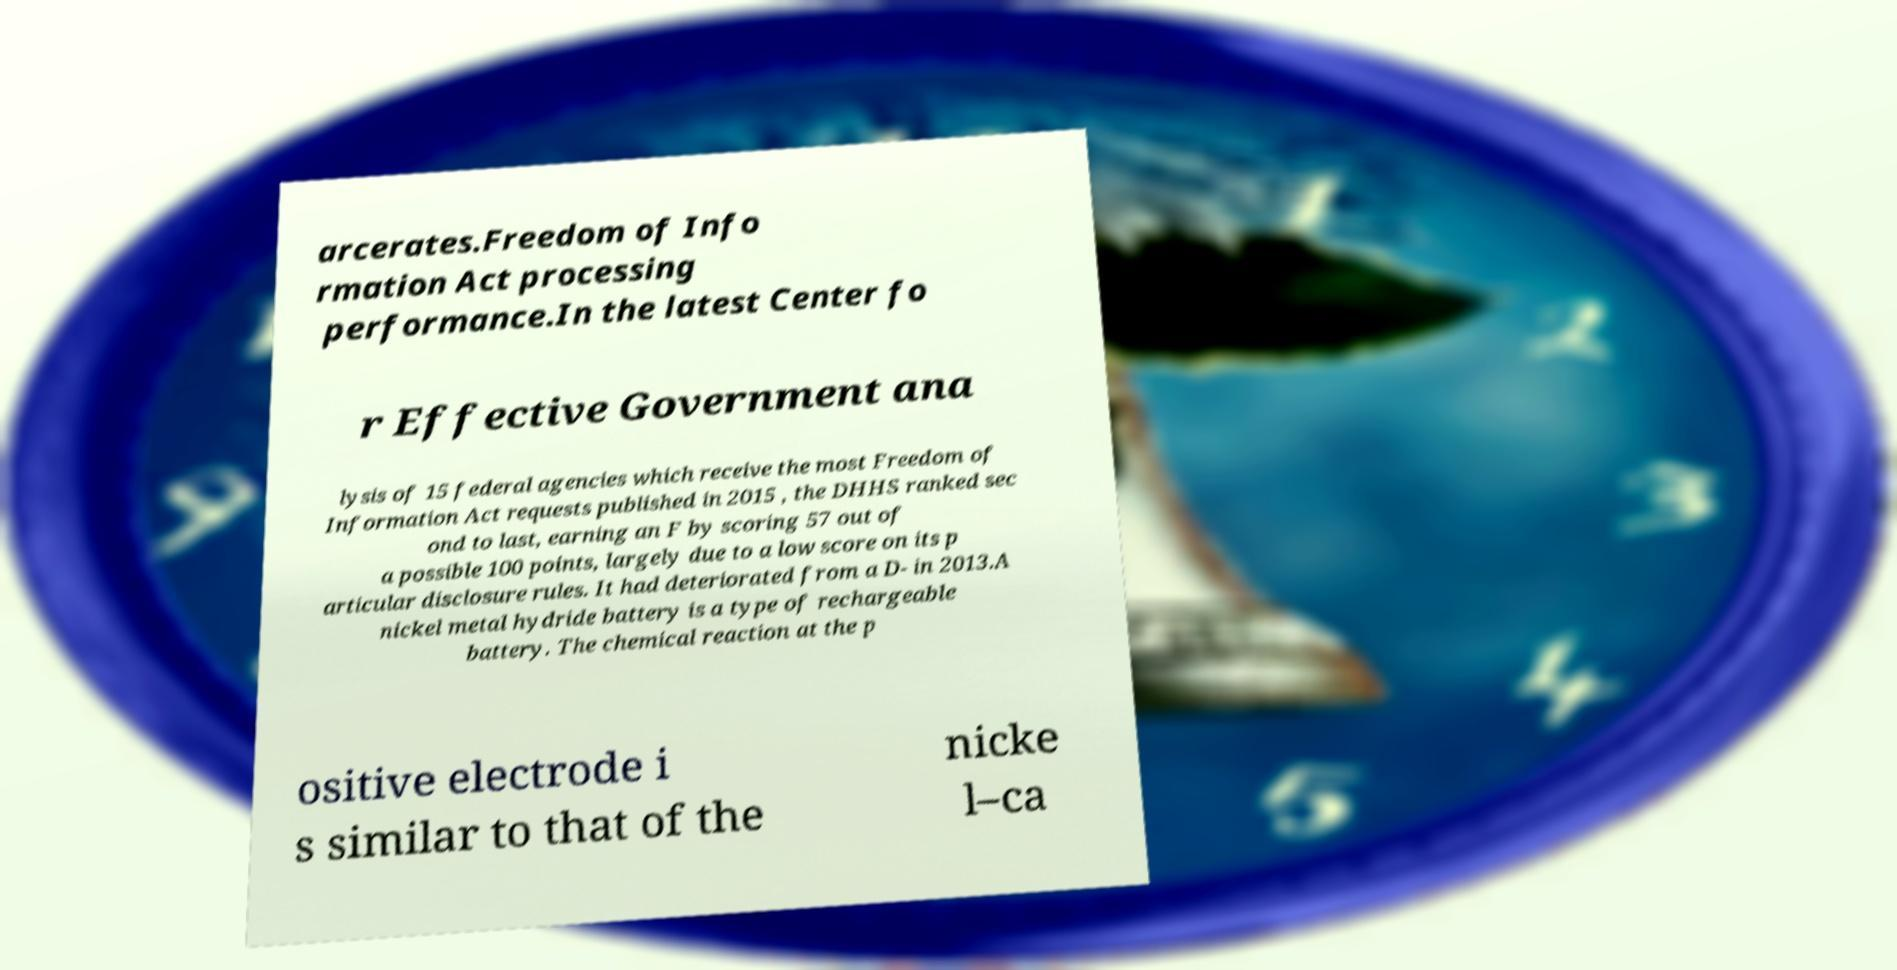Could you assist in decoding the text presented in this image and type it out clearly? arcerates.Freedom of Info rmation Act processing performance.In the latest Center fo r Effective Government ana lysis of 15 federal agencies which receive the most Freedom of Information Act requests published in 2015 , the DHHS ranked sec ond to last, earning an F by scoring 57 out of a possible 100 points, largely due to a low score on its p articular disclosure rules. It had deteriorated from a D- in 2013.A nickel metal hydride battery is a type of rechargeable battery. The chemical reaction at the p ositive electrode i s similar to that of the nicke l–ca 